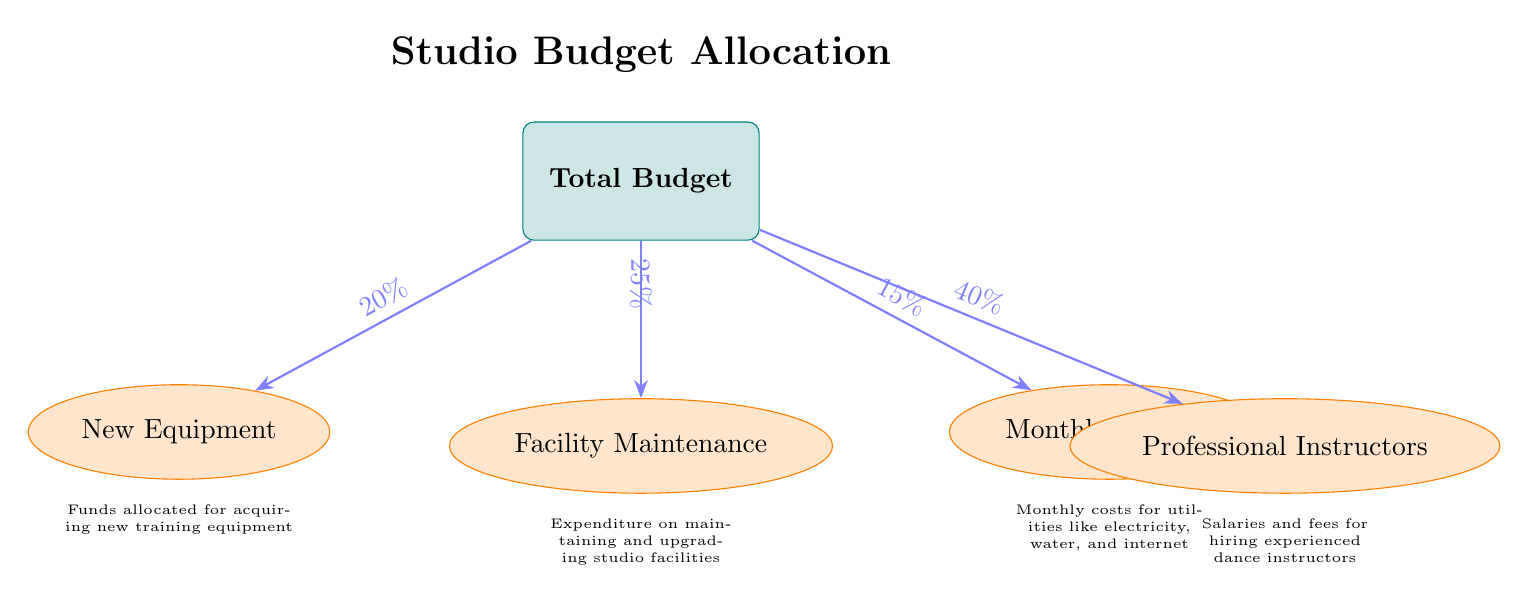What percentage of the total budget is allocated to new equipment? The diagram shows a node indicating that 20% of the total budget is allocated to new equipment. This information is represented as a label on the arrow pointing from the total budget node to the new equipment node.
Answer: 20% How much of the total budget is spent on professional instructors? The diagram clearly indicates that 40% of the total budget is allocated to professional instructors. This is identified from the label on the arrow connecting the total budget to the instructors node.
Answer: 40% Which category has the lowest percentage allocation? By examining the percentages indicated on the arrows, it is clear that the category with the lowest allocation is Monthly Utilities, which is at 15%. This is the smallest value among all the expenditure categories shown.
Answer: Monthly Utilities What is the total percentage of the budget allocated to maintaining existing facilities? The diagram specifies that 25% of the total budget is allocated for facility maintenance. This is derived directly from the label associated with the down arrow pointing towards the facility maintenance node.
Answer: 25% What is the relationship depicted between total budget and monthly utilities? The diagram shows a direct connection from the total budget node to the monthly utilities node, with an annotation indicating that 15% of the budget is allocated for this purpose. This illustrates that monthly utilities are a direct expenditure category linked to the overall budget.
Answer: 15% What two categories together account for 60% of the total budget? The combined total of Facility Maintenance (25%) and Professional Instructors (40%) results in 65% of the total budget. By summing the percentages allocated to these two nodes, it can be confirmed they collectively exceed the 60% threshold.
Answer: Facility Maintenance and Professional Instructors What type of expense is reflected in the arrow labeled “25%”? The label “25%” is associated with the arrow that connects the total budget node to the Facility Maintenance node, indicating that this percentage is allocated to the maintenance of existing studio facilities.
Answer: Facility Maintenance What is the total percentage of the remaining budget after subtracting the costs for new equipment and instructors? To find the remaining budget percentage after subtracting new equipment (20%) and instructors (40%), we calculate: 100% - (20% + 40%) = 40%. Thus, the total percentage remaining would consist of the maintenance (25%) and utilities (15%).
Answer: 40% 